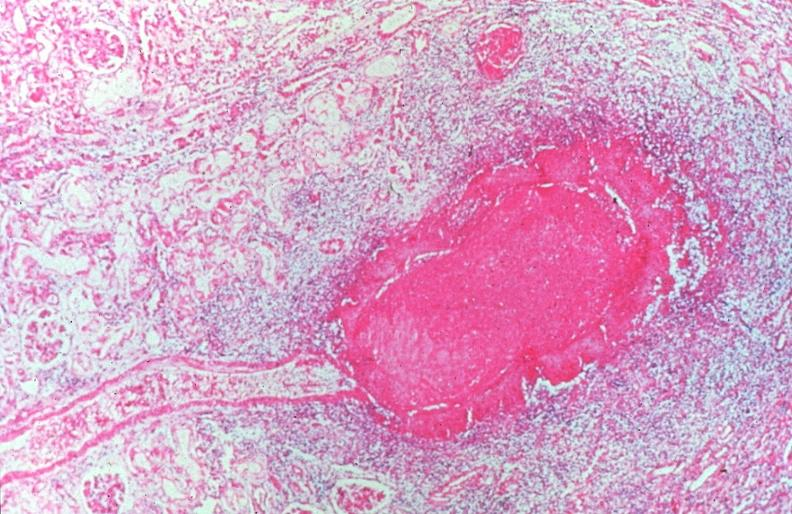where is this from?
Answer the question using a single word or phrase. Vasculature 